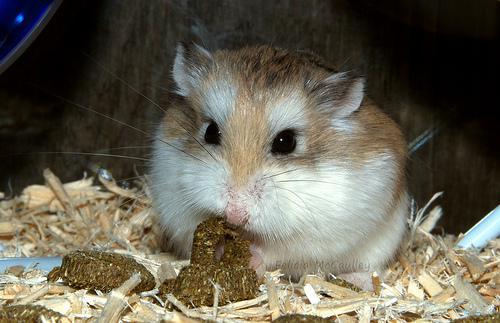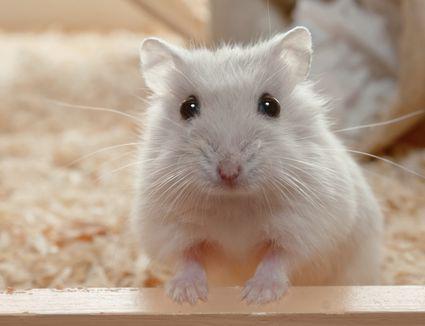The first image is the image on the left, the second image is the image on the right. Considering the images on both sides, is "Each image shows one hamster with food in front of it, and the right image features a hamster with a peach-colored face clutching a piece of food to its face." valid? Answer yes or no. No. The first image is the image on the left, the second image is the image on the right. Considering the images on both sides, is "Two hamsters are eating." valid? Answer yes or no. No. 